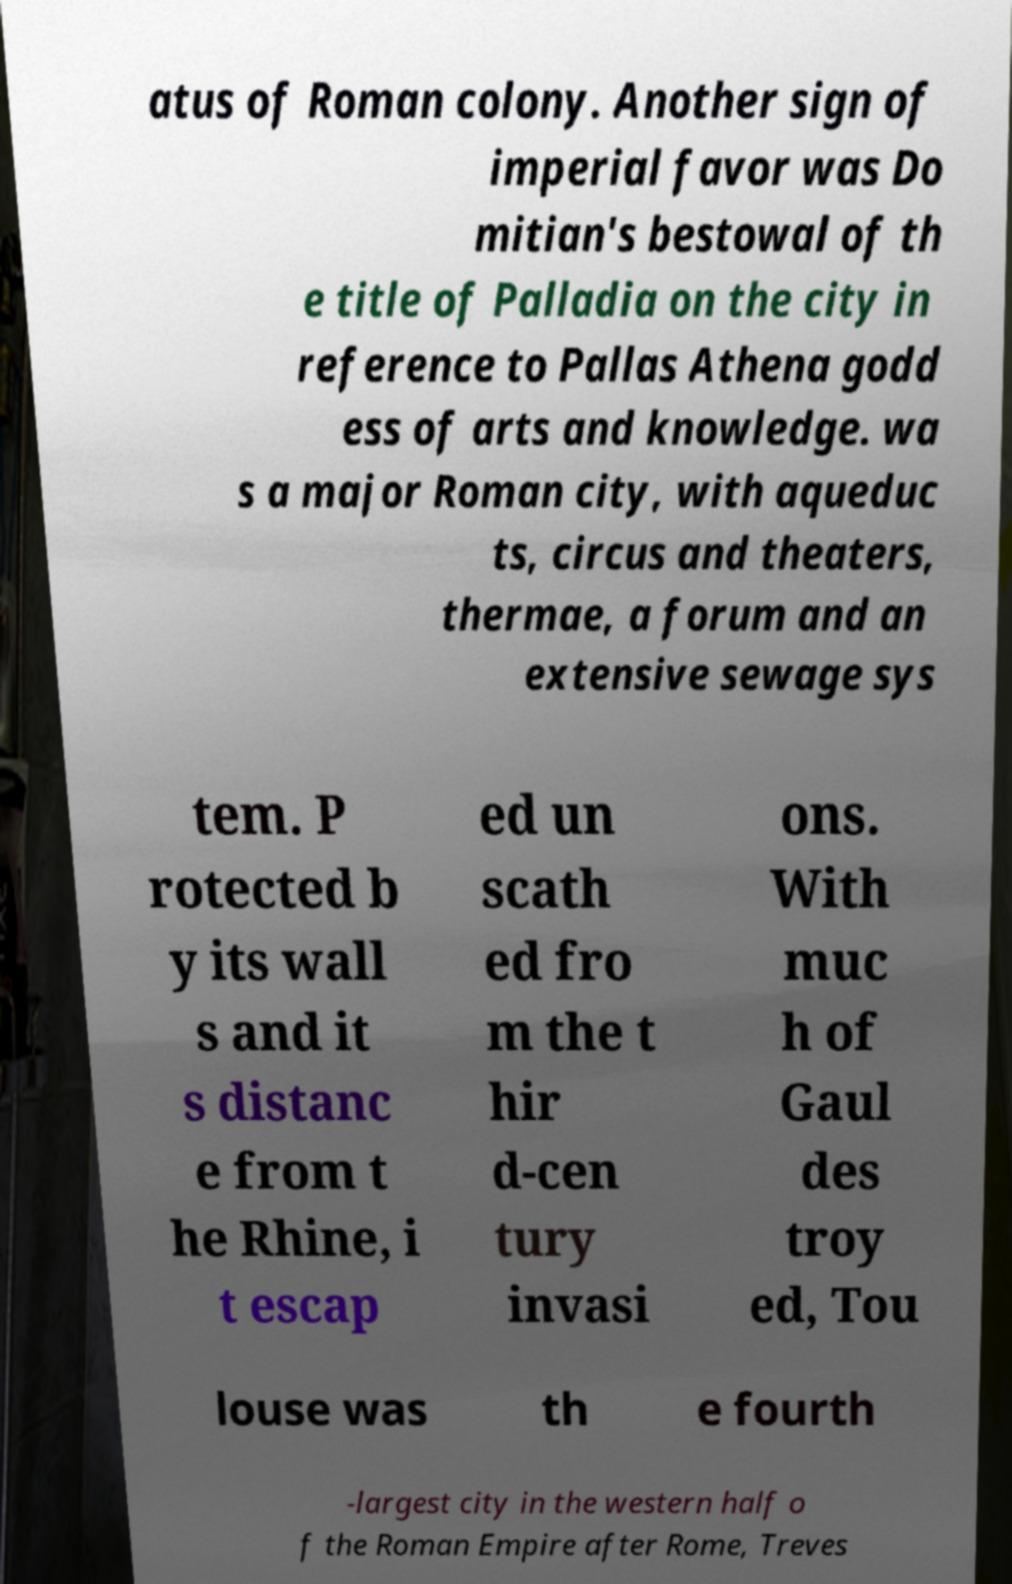Please identify and transcribe the text found in this image. atus of Roman colony. Another sign of imperial favor was Do mitian's bestowal of th e title of Palladia on the city in reference to Pallas Athena godd ess of arts and knowledge. wa s a major Roman city, with aqueduc ts, circus and theaters, thermae, a forum and an extensive sewage sys tem. P rotected b y its wall s and it s distanc e from t he Rhine, i t escap ed un scath ed fro m the t hir d-cen tury invasi ons. With muc h of Gaul des troy ed, Tou louse was th e fourth -largest city in the western half o f the Roman Empire after Rome, Treves 